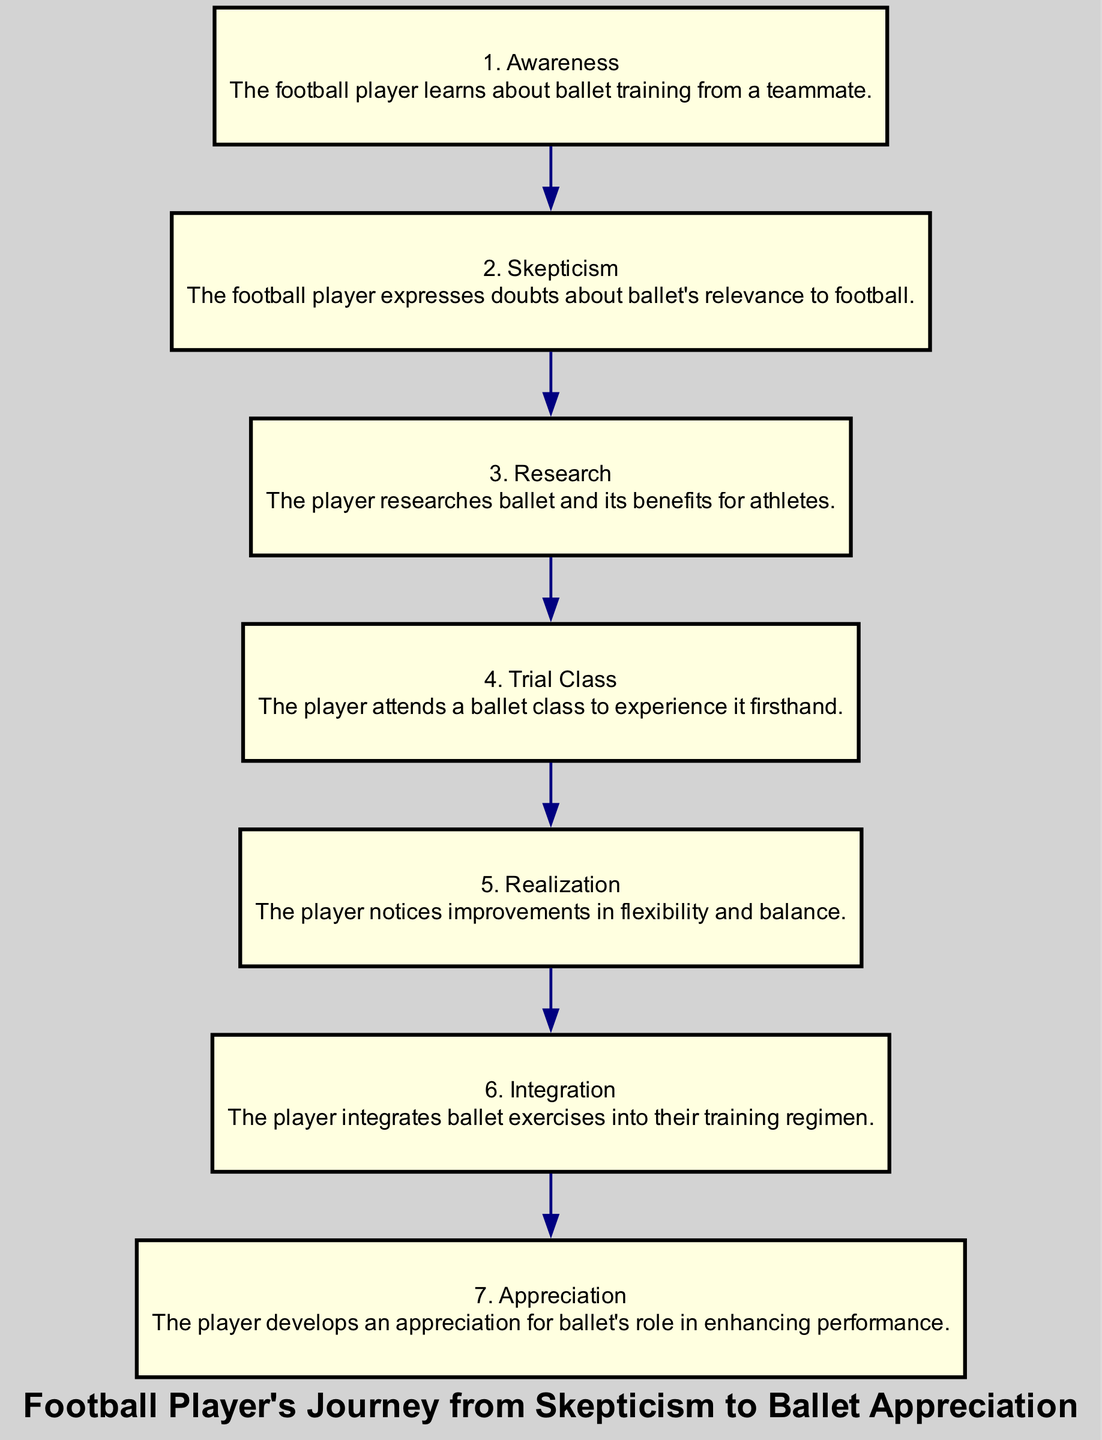What is the first action in the diagram? The first action is listed as "Awareness," which is represented by the first node.
Answer: Awareness How many total steps are illustrated in the diagram? The diagram lists seven steps, each labeled with a consecutive number.
Answer: 7 Which action follows "Skepticism"? The action that comes after "Skepticism" is "Research," indicated as the third step in the sequence.
Answer: Research What does the player notice after attending the trial class? After attending the trial class, the player realizes improvements in flexibility and balance, which is stated in the description of the fifth step.
Answer: Improvements in flexibility and balance Which action is directly connected to "Integration"? The action directly preceding "Integration," which is the sixth step, is "Realization." The sequence flows from realization to integration.
Answer: Realization How many edges connect the nodes in the diagram? Each of the six transitions from one action to the next represents an edge, so there are six edges altogether.
Answer: 6 Describe the transition from "Trial Class" to "Realization." After the player attends the trial class, they transition to "Realization," where they note the benefits of ballet training, specifically in flexibility and balance. This progression shows the player's growing understanding of ballet's impact.
Answer: The player notices improvements in flexibility and balance What is the last step in the sequence? The last step in the sequence is "Appreciation," which highlights the player's developed appreciation for ballet's role.
Answer: Appreciation 